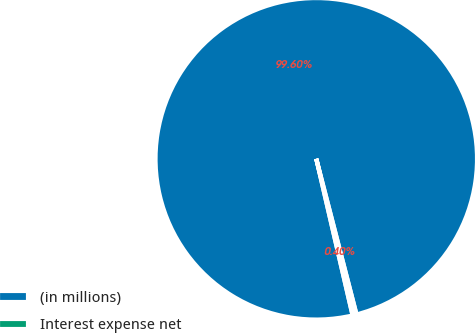<chart> <loc_0><loc_0><loc_500><loc_500><pie_chart><fcel>(in millions)<fcel>Interest expense net<nl><fcel>99.6%<fcel>0.4%<nl></chart> 